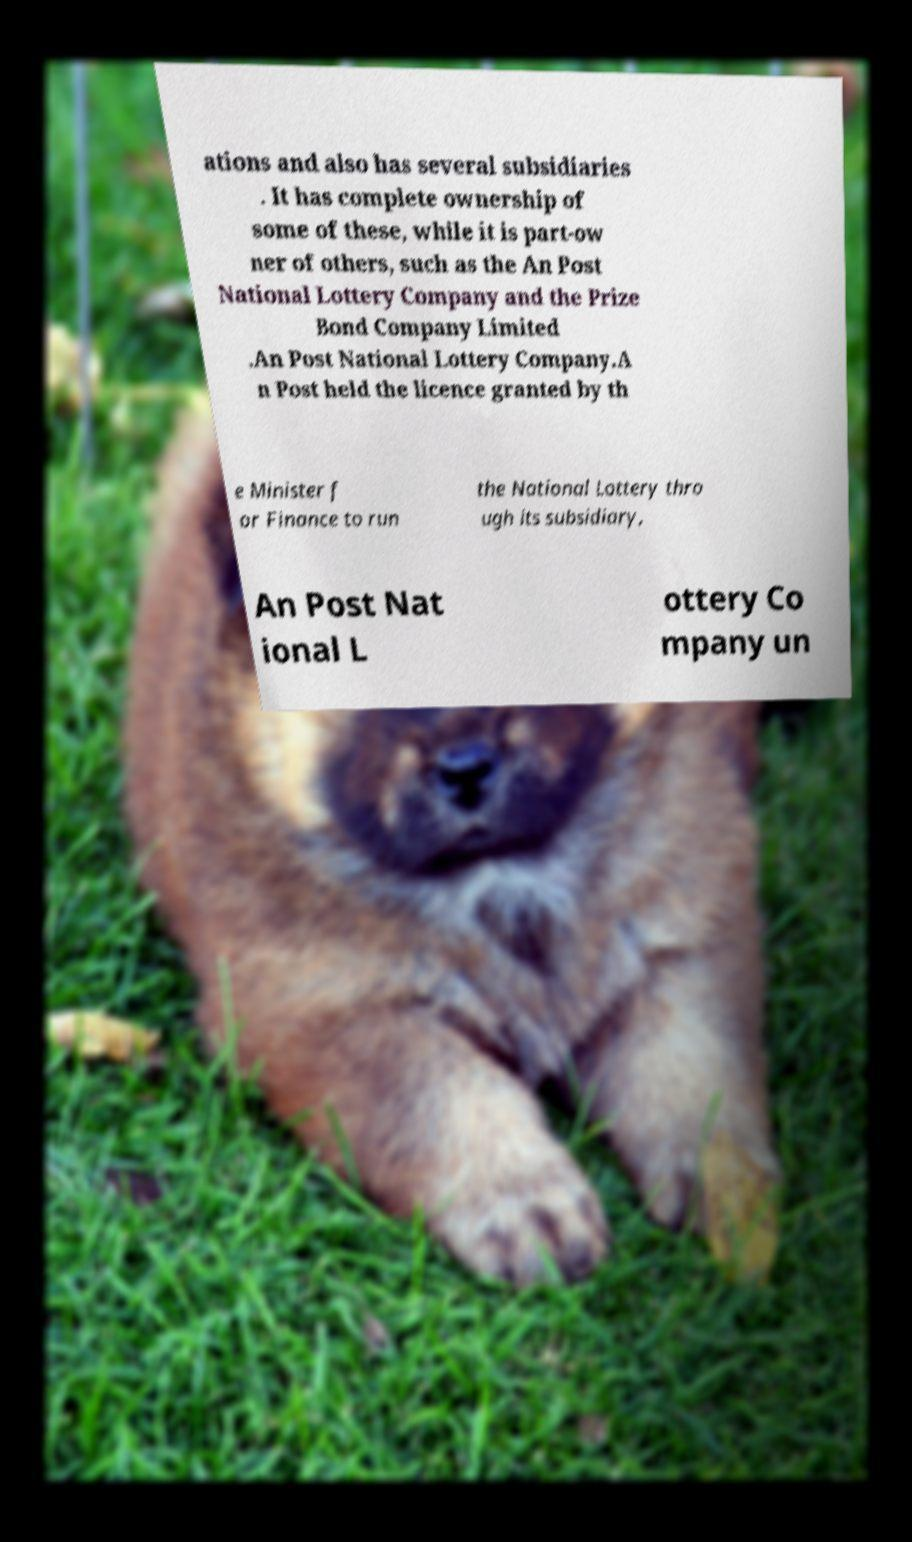For documentation purposes, I need the text within this image transcribed. Could you provide that? ations and also has several subsidiaries . It has complete ownership of some of these, while it is part-ow ner of others, such as the An Post National Lottery Company and the Prize Bond Company Limited .An Post National Lottery Company.A n Post held the licence granted by th e Minister f or Finance to run the National Lottery thro ugh its subsidiary, An Post Nat ional L ottery Co mpany un 